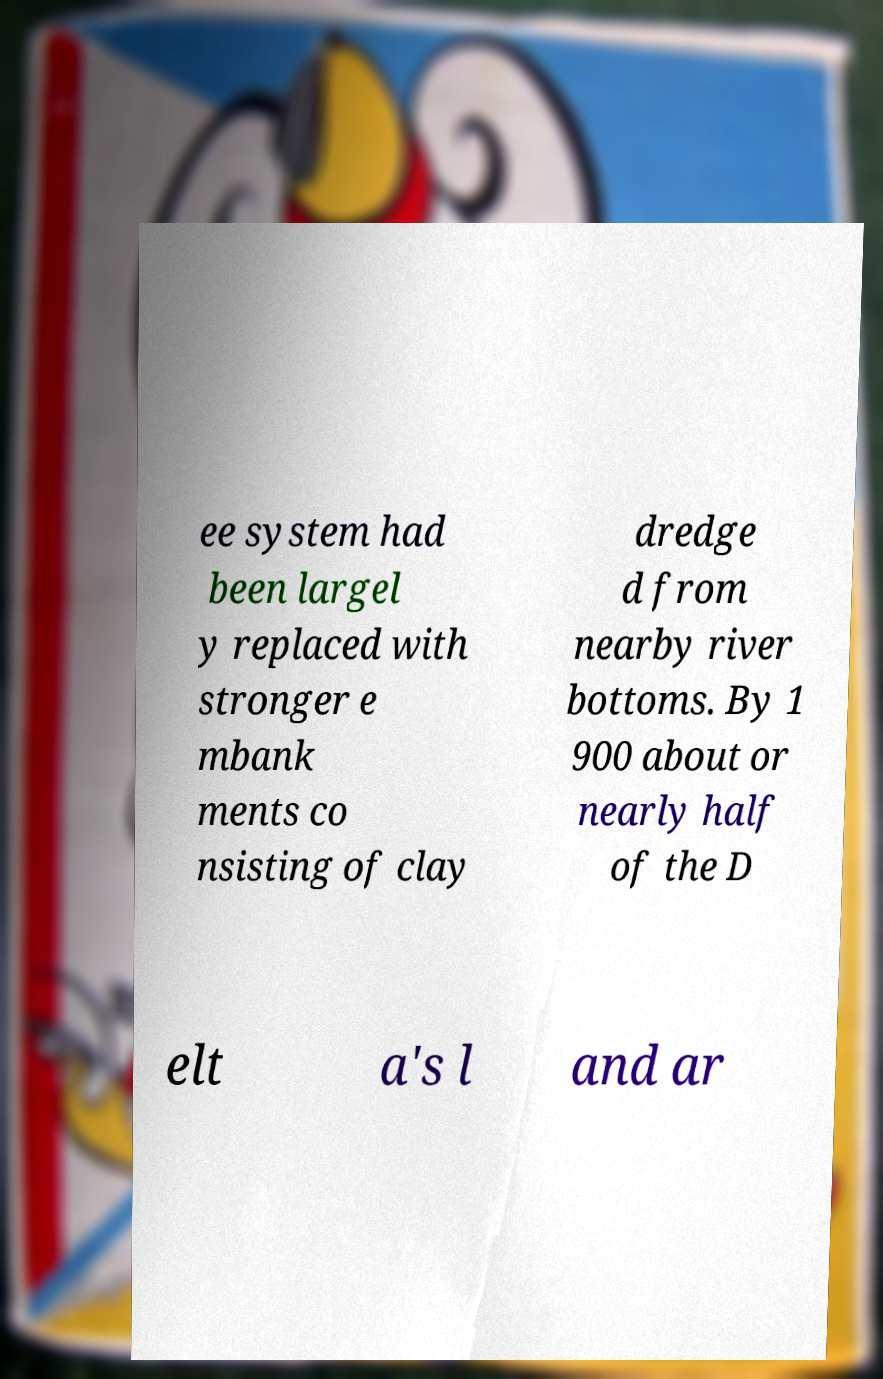Please identify and transcribe the text found in this image. ee system had been largel y replaced with stronger e mbank ments co nsisting of clay dredge d from nearby river bottoms. By 1 900 about or nearly half of the D elt a's l and ar 